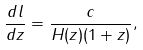<formula> <loc_0><loc_0><loc_500><loc_500>\frac { d l } { d z } = \frac { c } { H ( z ) ( 1 + z ) } ,</formula> 